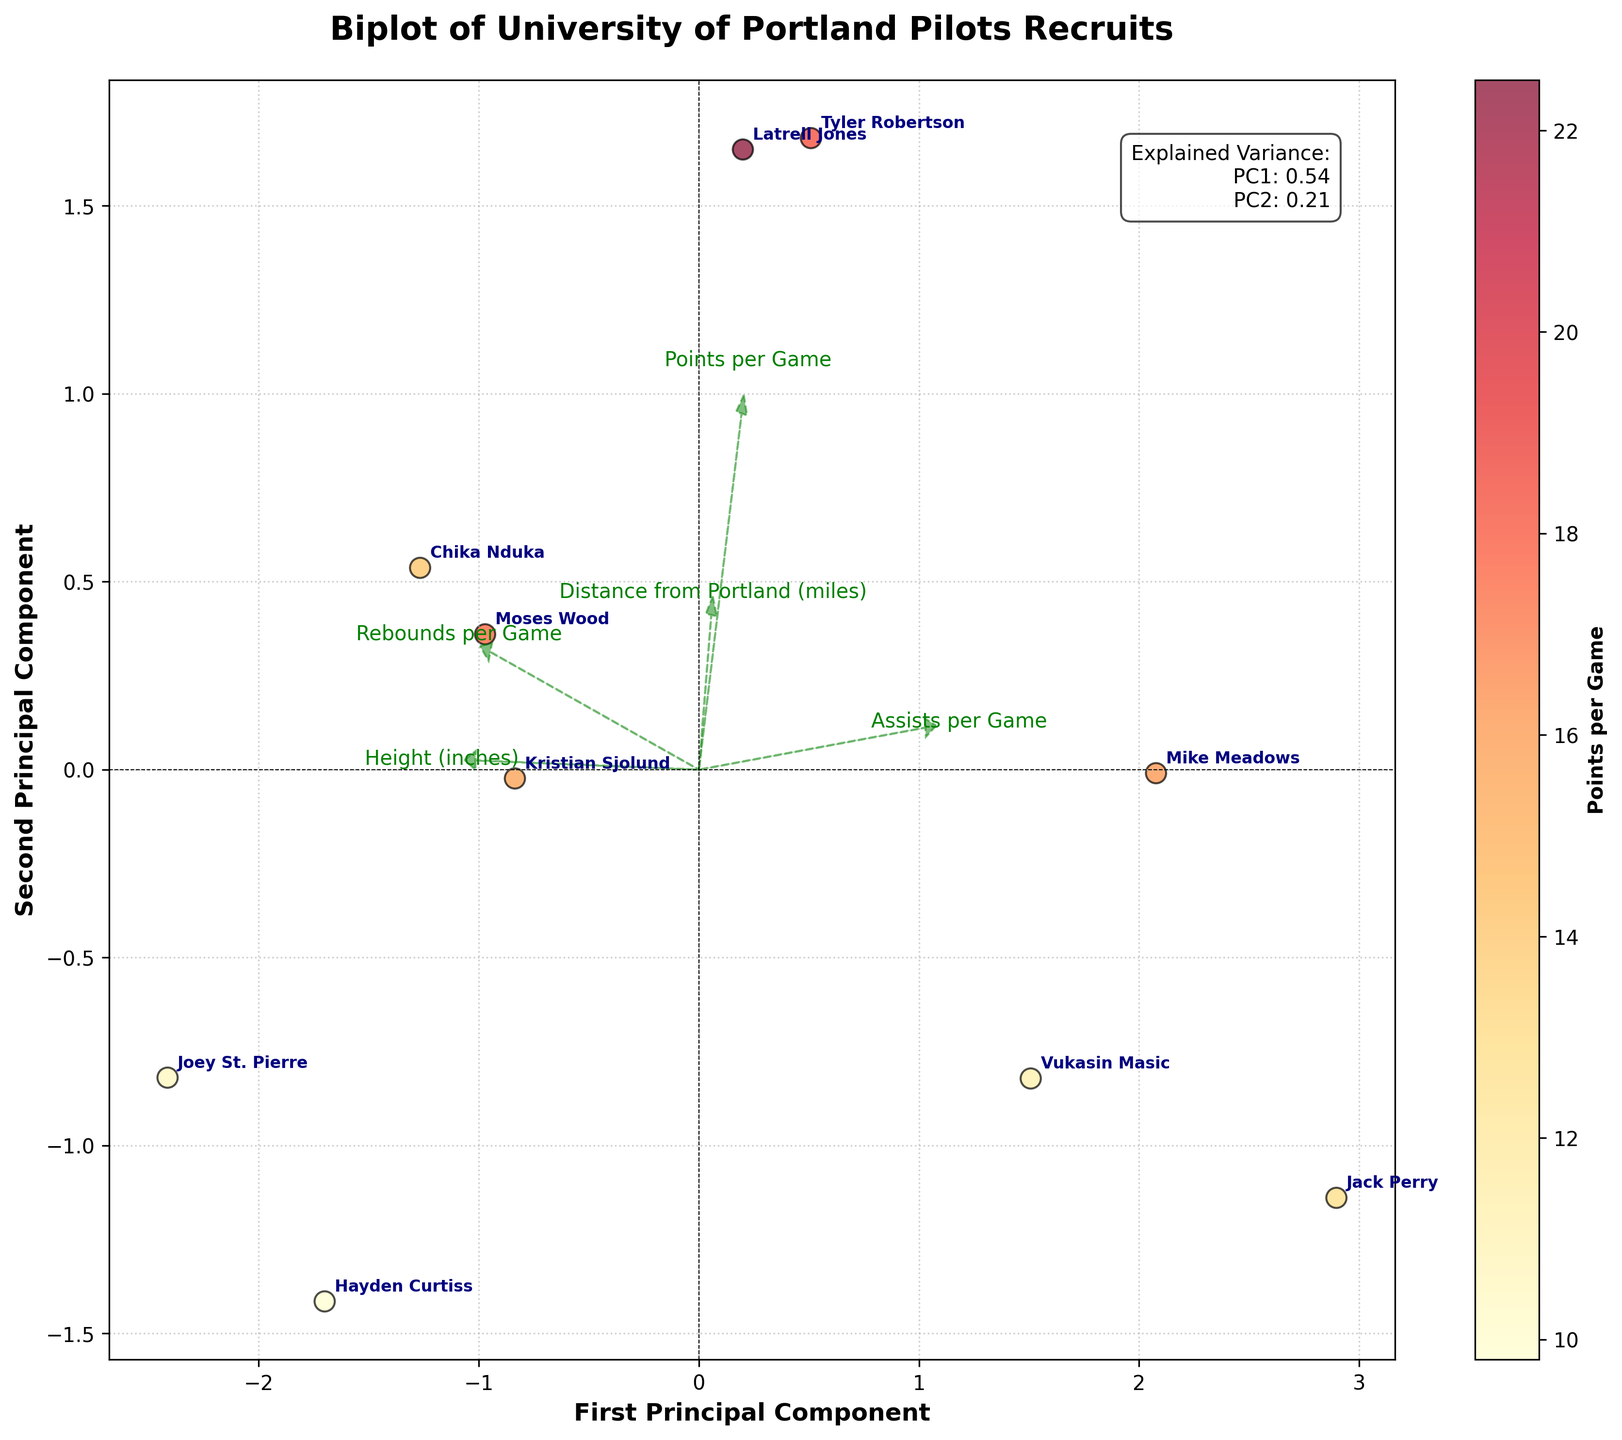How many players are represented in the biplot? The annotations in the figure mark the names of the players, each player is represented once. By counting the unique annotations, we find the total number of players.
Answer: 10 Which player is closest to Portland? The biplot's arrows indicate the distance from Portland. Latrell Jones is positioned closest to the arrow indicating ‘Distance from Portland (miles)’ in the negative direction of the first principal component.
Answer: Latrell Jones Which feature vector most strongly correlates with the second principal component? In a biplot, the feature vectors are represented as arrows, and their correlation with the principal components can be judged by the angle with the axes. The arrow representing 'Rebounds per Game' is closest to the second principal component axis.
Answer: 'Rebounds per Game' Who has the highest points per game and how can you tell? Points per game is represented by the color intensity on the scatter plot, with a color bar ranging from yellow to red. Tyler Robertson is the player nearest to the red end of the spectrum.
Answer: Tyler Robertson Which players are similar in terms of their PCA scores? Players close to each other on the biplot have similar principal component scores. Tyler Robertson and Kristian Sjolund are positioned near each other on the plot.
Answer: Tyler Robertson and Kristian Sjolund What is the explained variance ratio of the first principal component? The explained variance ratio is provided in the text box within the plot. The first principal component's value can be directly read from the box.
Answer: 0.42 Compare Jack Perry and Moses Wood based on their position in the biplot. The relative positions of Jack Perry and Moses Wood can be analyzed. Jack Perry is closer to the bottom of the plot and further left, which may suggest fewer rebounds and distance from Portland, whereas Moses Wood is positioned relatively higher and to the right.
Answer: Jack Perry has fewer rebounds and assists, and is closer to Portland than Moses Wood Which feature is least correlated with the first principal component? The correlation is judged by the length and direction of the arrows. The arrow for 'Height (inches)' is closest to the y-axis, indicating a weaker correlation with the first principal component.
Answer: 'Height (inches)' What is the total number of principal components shown on the biplot? A biplot typically displays two principal components in a two-dimensional plot.
Answer: 2 